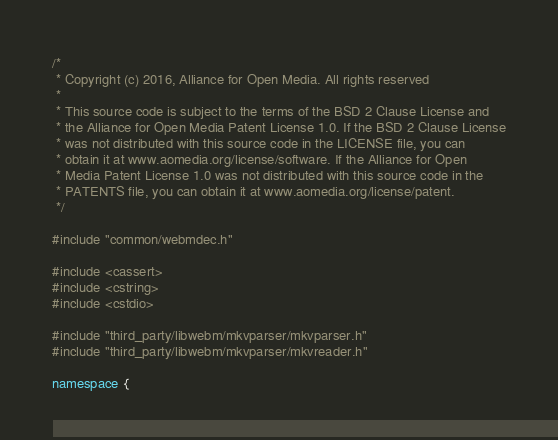<code> <loc_0><loc_0><loc_500><loc_500><_C++_>/*
 * Copyright (c) 2016, Alliance for Open Media. All rights reserved
 *
 * This source code is subject to the terms of the BSD 2 Clause License and
 * the Alliance for Open Media Patent License 1.0. If the BSD 2 Clause License
 * was not distributed with this source code in the LICENSE file, you can
 * obtain it at www.aomedia.org/license/software. If the Alliance for Open
 * Media Patent License 1.0 was not distributed with this source code in the
 * PATENTS file, you can obtain it at www.aomedia.org/license/patent.
 */

#include "common/webmdec.h"

#include <cassert>
#include <cstring>
#include <cstdio>

#include "third_party/libwebm/mkvparser/mkvparser.h"
#include "third_party/libwebm/mkvparser/mkvreader.h"

namespace {
</code> 